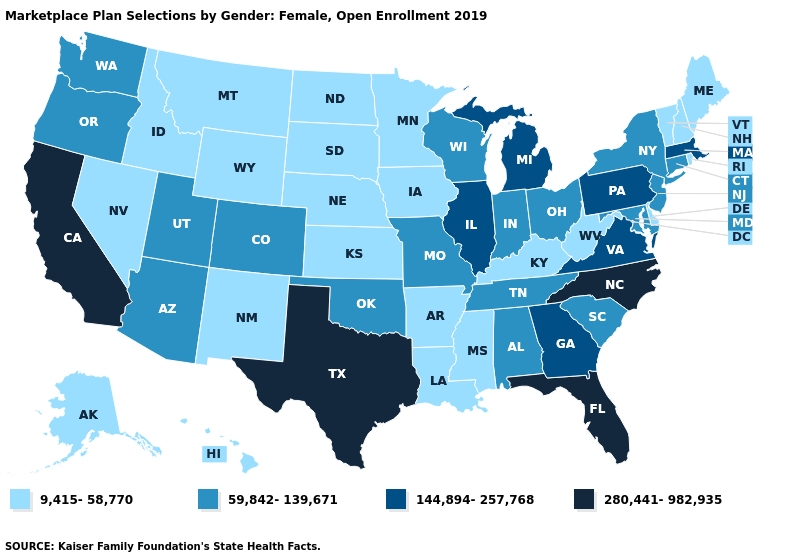What is the highest value in states that border Montana?
Be succinct. 9,415-58,770. What is the value of South Dakota?
Answer briefly. 9,415-58,770. Name the states that have a value in the range 144,894-257,768?
Write a very short answer. Georgia, Illinois, Massachusetts, Michigan, Pennsylvania, Virginia. Does Colorado have the lowest value in the West?
Short answer required. No. What is the value of Missouri?
Give a very brief answer. 59,842-139,671. Name the states that have a value in the range 59,842-139,671?
Write a very short answer. Alabama, Arizona, Colorado, Connecticut, Indiana, Maryland, Missouri, New Jersey, New York, Ohio, Oklahoma, Oregon, South Carolina, Tennessee, Utah, Washington, Wisconsin. Name the states that have a value in the range 144,894-257,768?
Be succinct. Georgia, Illinois, Massachusetts, Michigan, Pennsylvania, Virginia. Does Nevada have the lowest value in the USA?
Answer briefly. Yes. What is the value of Arkansas?
Give a very brief answer. 9,415-58,770. Does the first symbol in the legend represent the smallest category?
Be succinct. Yes. What is the value of Vermont?
Write a very short answer. 9,415-58,770. Does Florida have the highest value in the USA?
Quick response, please. Yes. What is the value of Illinois?
Short answer required. 144,894-257,768. What is the lowest value in the USA?
Keep it brief. 9,415-58,770. How many symbols are there in the legend?
Be succinct. 4. 